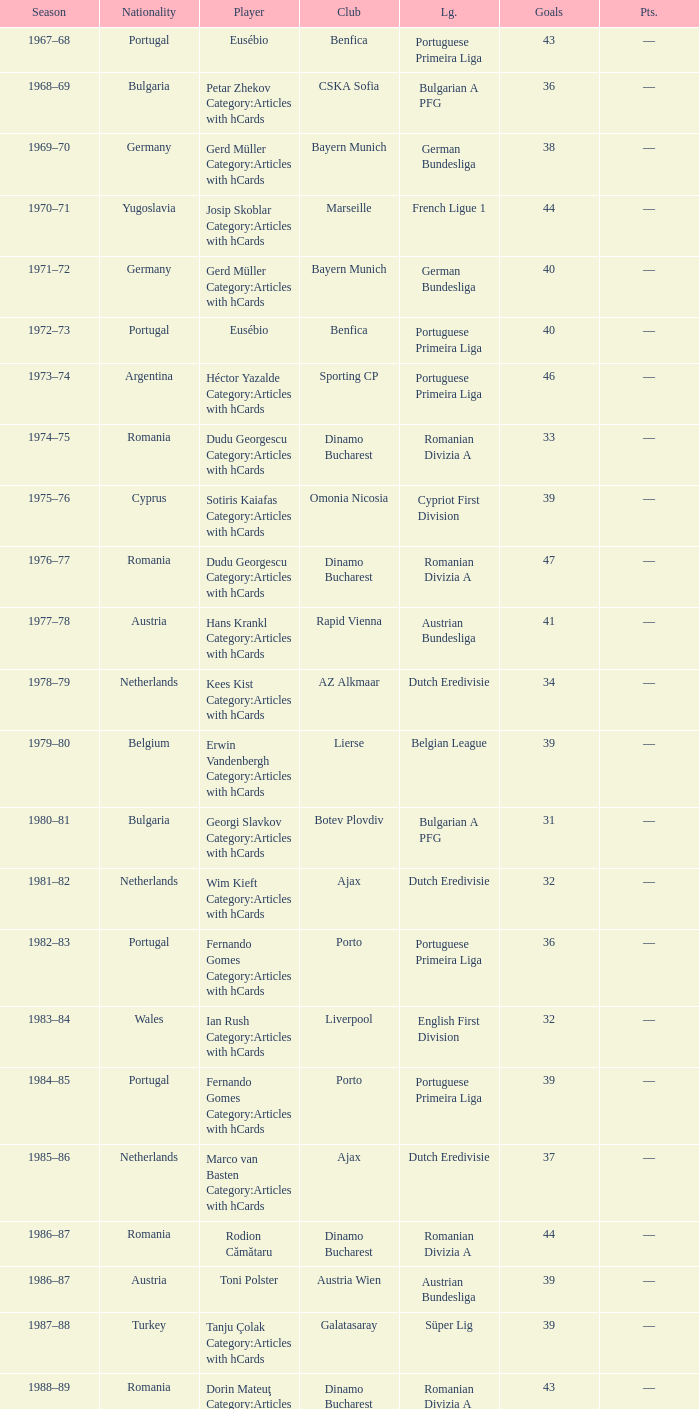Which league's nationality was Italy when there were 62 points? Italian Serie A. 